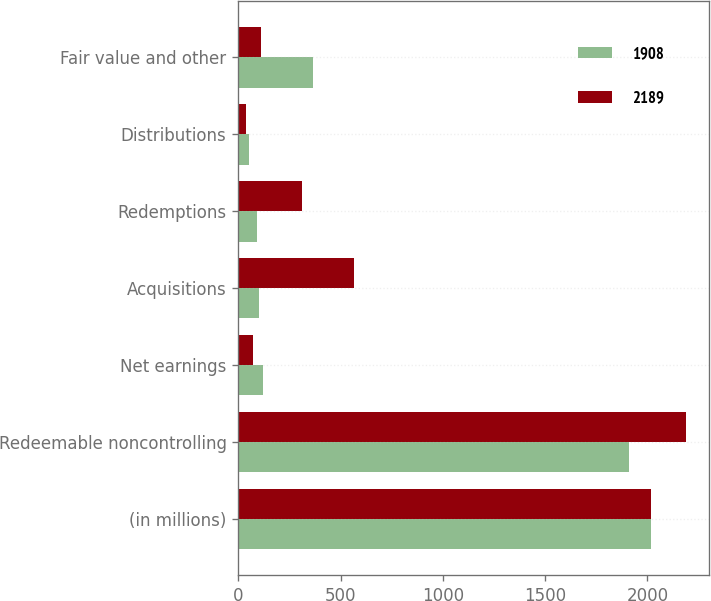<chart> <loc_0><loc_0><loc_500><loc_500><stacked_bar_chart><ecel><fcel>(in millions)<fcel>Redeemable noncontrolling<fcel>Net earnings<fcel>Acquisitions<fcel>Redemptions<fcel>Distributions<fcel>Fair value and other<nl><fcel>1908<fcel>2018<fcel>1908<fcel>123<fcel>102<fcel>90<fcel>53<fcel>363<nl><fcel>2189<fcel>2017<fcel>2189<fcel>71<fcel>565<fcel>309<fcel>38<fcel>112<nl></chart> 